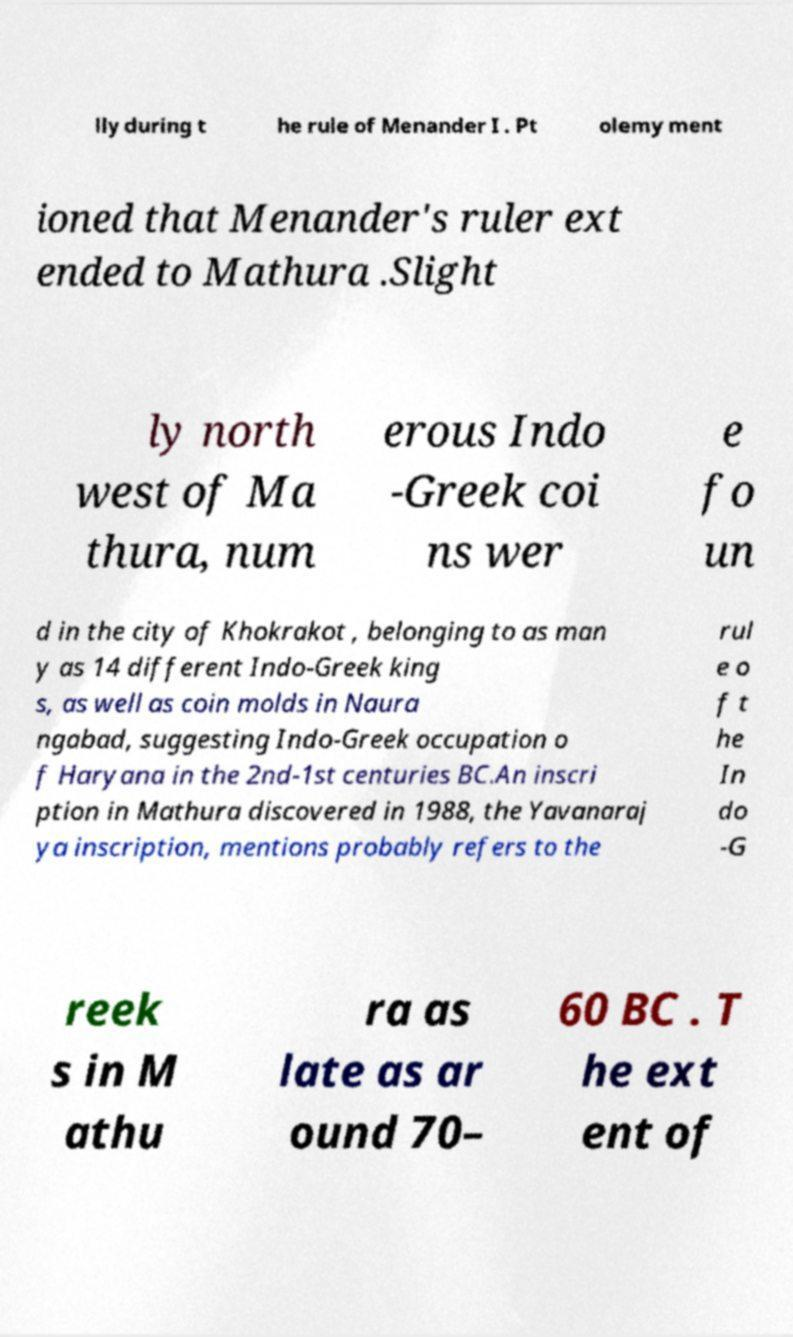Can you accurately transcribe the text from the provided image for me? lly during t he rule of Menander I . Pt olemy ment ioned that Menander's ruler ext ended to Mathura .Slight ly north west of Ma thura, num erous Indo -Greek coi ns wer e fo un d in the city of Khokrakot , belonging to as man y as 14 different Indo-Greek king s, as well as coin molds in Naura ngabad, suggesting Indo-Greek occupation o f Haryana in the 2nd-1st centuries BC.An inscri ption in Mathura discovered in 1988, the Yavanaraj ya inscription, mentions probably refers to the rul e o f t he In do -G reek s in M athu ra as late as ar ound 70– 60 BC . T he ext ent of 